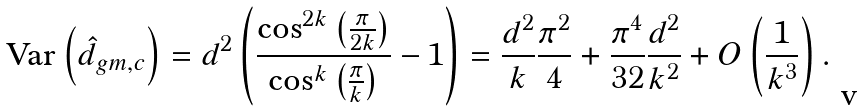<formula> <loc_0><loc_0><loc_500><loc_500>\text {Var} \left ( \hat { d } _ { g m , c } \right ) & = d ^ { 2 } \left ( \frac { \cos ^ { 2 k } \left ( \frac { \pi } { 2 k } \right ) } { \cos ^ { k } \left ( \frac { \pi } { k } \right ) } - 1 \right ) = \frac { d ^ { 2 } } { k } \frac { \pi ^ { 2 } } { 4 } + \frac { \pi ^ { 4 } } { 3 2 } \frac { d ^ { 2 } } { k ^ { 2 } } + O \left ( \frac { 1 } { k ^ { 3 } } \right ) .</formula> 